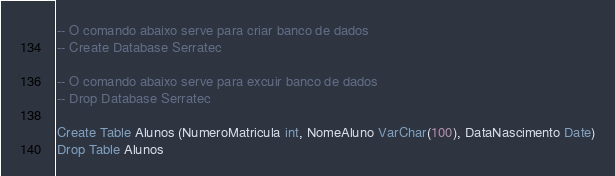<code> <loc_0><loc_0><loc_500><loc_500><_SQL_>-- O comando abaixo serve para criar banco de dados
-- Create Database Serratec

-- O comando abaixo serve para excuir banco de dados
-- Drop Database Serratec

Create Table Alunos (NumeroMatricula int, NomeAluno VarChar(100), DataNascimento Date)
Drop Table Alunos
</code> 